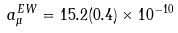Convert formula to latex. <formula><loc_0><loc_0><loc_500><loc_500>a _ { \mu } ^ { E W } = 1 5 . 2 ( 0 . 4 ) \times 1 0 ^ { - 1 0 }</formula> 